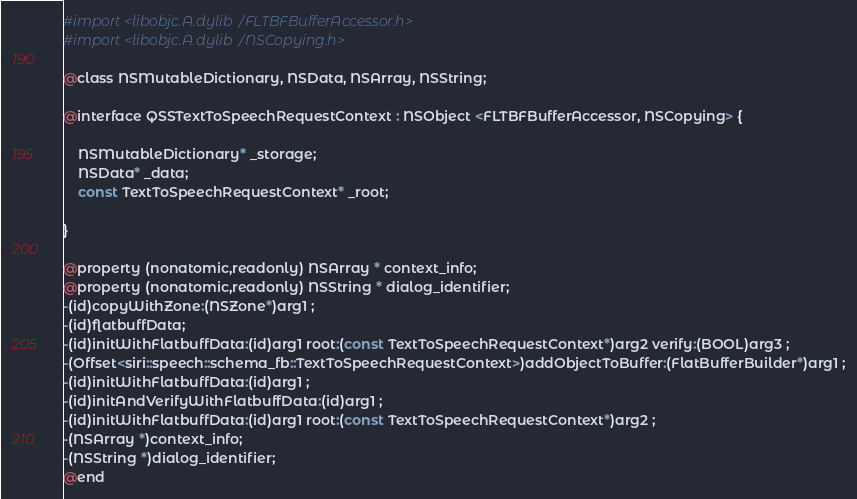Convert code to text. <code><loc_0><loc_0><loc_500><loc_500><_C_>#import <libobjc.A.dylib/FLTBFBufferAccessor.h>
#import <libobjc.A.dylib/NSCopying.h>

@class NSMutableDictionary, NSData, NSArray, NSString;

@interface QSSTextToSpeechRequestContext : NSObject <FLTBFBufferAccessor, NSCopying> {

	NSMutableDictionary* _storage;
	NSData* _data;
	const TextToSpeechRequestContext* _root;

}

@property (nonatomic,readonly) NSArray * context_info; 
@property (nonatomic,readonly) NSString * dialog_identifier; 
-(id)copyWithZone:(NSZone*)arg1 ;
-(id)flatbuffData;
-(id)initWithFlatbuffData:(id)arg1 root:(const TextToSpeechRequestContext*)arg2 verify:(BOOL)arg3 ;
-(Offset<siri::speech::schema_fb::TextToSpeechRequestContext>)addObjectToBuffer:(FlatBufferBuilder*)arg1 ;
-(id)initWithFlatbuffData:(id)arg1 ;
-(id)initAndVerifyWithFlatbuffData:(id)arg1 ;
-(id)initWithFlatbuffData:(id)arg1 root:(const TextToSpeechRequestContext*)arg2 ;
-(NSArray *)context_info;
-(NSString *)dialog_identifier;
@end

</code> 